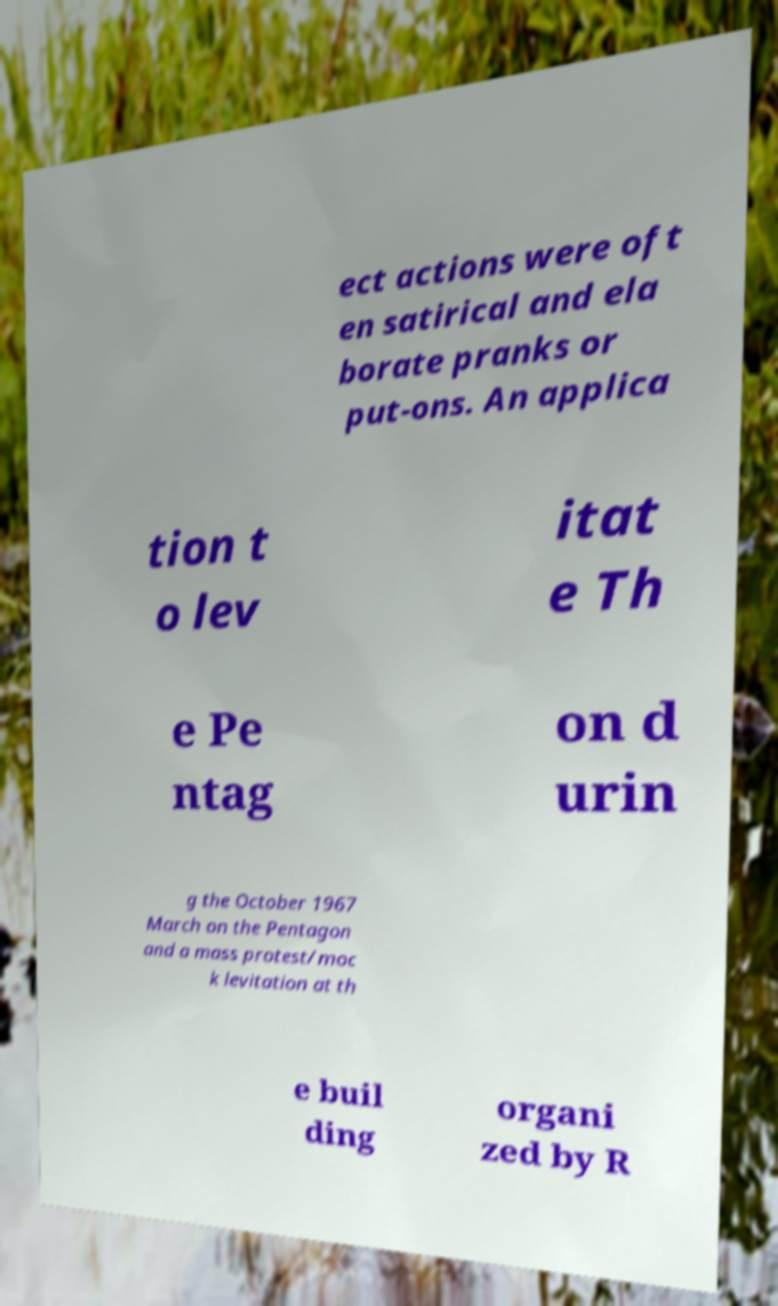Can you read and provide the text displayed in the image?This photo seems to have some interesting text. Can you extract and type it out for me? ect actions were oft en satirical and ela borate pranks or put-ons. An applica tion t o lev itat e Th e Pe ntag on d urin g the October 1967 March on the Pentagon and a mass protest/moc k levitation at th e buil ding organi zed by R 